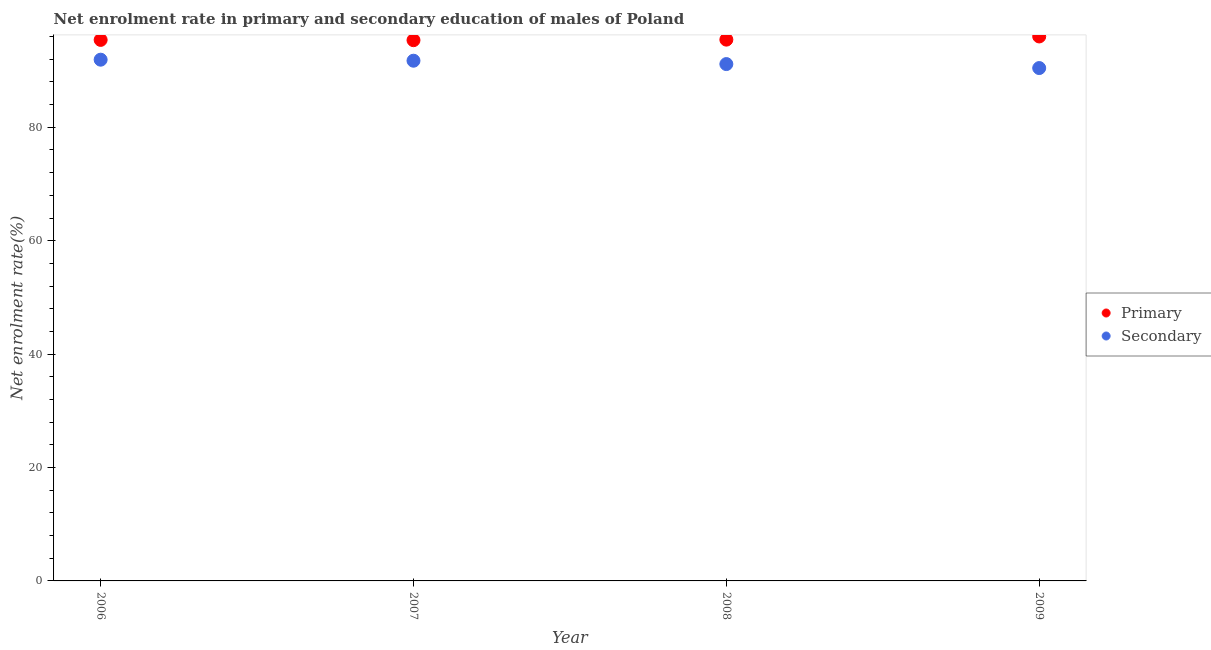How many different coloured dotlines are there?
Ensure brevity in your answer.  2. Is the number of dotlines equal to the number of legend labels?
Your answer should be very brief. Yes. What is the enrollment rate in secondary education in 2008?
Offer a terse response. 91.15. Across all years, what is the maximum enrollment rate in primary education?
Offer a very short reply. 96.02. Across all years, what is the minimum enrollment rate in primary education?
Your answer should be very brief. 95.36. What is the total enrollment rate in secondary education in the graph?
Ensure brevity in your answer.  365.26. What is the difference between the enrollment rate in secondary education in 2008 and that in 2009?
Make the answer very short. 0.7. What is the difference between the enrollment rate in secondary education in 2009 and the enrollment rate in primary education in 2008?
Provide a succinct answer. -5.01. What is the average enrollment rate in secondary education per year?
Your answer should be very brief. 91.32. In the year 2007, what is the difference between the enrollment rate in primary education and enrollment rate in secondary education?
Give a very brief answer. 3.62. In how many years, is the enrollment rate in primary education greater than 16 %?
Make the answer very short. 4. What is the ratio of the enrollment rate in secondary education in 2008 to that in 2009?
Your answer should be compact. 1.01. Is the enrollment rate in secondary education in 2008 less than that in 2009?
Offer a terse response. No. What is the difference between the highest and the second highest enrollment rate in secondary education?
Keep it short and to the point. 0.18. What is the difference between the highest and the lowest enrollment rate in primary education?
Ensure brevity in your answer.  0.66. Is the sum of the enrollment rate in secondary education in 2007 and 2009 greater than the maximum enrollment rate in primary education across all years?
Provide a short and direct response. Yes. Does the enrollment rate in primary education monotonically increase over the years?
Your answer should be compact. No. Is the enrollment rate in primary education strictly less than the enrollment rate in secondary education over the years?
Make the answer very short. No. What is the difference between two consecutive major ticks on the Y-axis?
Your response must be concise. 20. Are the values on the major ticks of Y-axis written in scientific E-notation?
Your answer should be compact. No. Does the graph contain any zero values?
Provide a succinct answer. No. Does the graph contain grids?
Your answer should be compact. No. How many legend labels are there?
Provide a short and direct response. 2. What is the title of the graph?
Make the answer very short. Net enrolment rate in primary and secondary education of males of Poland. What is the label or title of the X-axis?
Provide a succinct answer. Year. What is the label or title of the Y-axis?
Your answer should be very brief. Net enrolment rate(%). What is the Net enrolment rate(%) of Primary in 2006?
Provide a succinct answer. 95.41. What is the Net enrolment rate(%) in Secondary in 2006?
Your answer should be very brief. 91.92. What is the Net enrolment rate(%) of Primary in 2007?
Offer a very short reply. 95.36. What is the Net enrolment rate(%) in Secondary in 2007?
Offer a terse response. 91.74. What is the Net enrolment rate(%) of Primary in 2008?
Keep it short and to the point. 95.46. What is the Net enrolment rate(%) in Secondary in 2008?
Provide a succinct answer. 91.15. What is the Net enrolment rate(%) in Primary in 2009?
Offer a very short reply. 96.02. What is the Net enrolment rate(%) in Secondary in 2009?
Give a very brief answer. 90.45. Across all years, what is the maximum Net enrolment rate(%) in Primary?
Keep it short and to the point. 96.02. Across all years, what is the maximum Net enrolment rate(%) of Secondary?
Your answer should be compact. 91.92. Across all years, what is the minimum Net enrolment rate(%) of Primary?
Your response must be concise. 95.36. Across all years, what is the minimum Net enrolment rate(%) of Secondary?
Offer a very short reply. 90.45. What is the total Net enrolment rate(%) of Primary in the graph?
Provide a short and direct response. 382.26. What is the total Net enrolment rate(%) of Secondary in the graph?
Your answer should be very brief. 365.26. What is the difference between the Net enrolment rate(%) in Primary in 2006 and that in 2007?
Provide a short and direct response. 0.05. What is the difference between the Net enrolment rate(%) in Secondary in 2006 and that in 2007?
Ensure brevity in your answer.  0.18. What is the difference between the Net enrolment rate(%) in Primary in 2006 and that in 2008?
Offer a terse response. -0.05. What is the difference between the Net enrolment rate(%) in Secondary in 2006 and that in 2008?
Offer a terse response. 0.77. What is the difference between the Net enrolment rate(%) of Primary in 2006 and that in 2009?
Offer a very short reply. -0.61. What is the difference between the Net enrolment rate(%) in Secondary in 2006 and that in 2009?
Your answer should be very brief. 1.48. What is the difference between the Net enrolment rate(%) in Primary in 2007 and that in 2008?
Your answer should be compact. -0.1. What is the difference between the Net enrolment rate(%) of Secondary in 2007 and that in 2008?
Give a very brief answer. 0.59. What is the difference between the Net enrolment rate(%) in Primary in 2007 and that in 2009?
Make the answer very short. -0.66. What is the difference between the Net enrolment rate(%) of Secondary in 2007 and that in 2009?
Provide a succinct answer. 1.3. What is the difference between the Net enrolment rate(%) in Primary in 2008 and that in 2009?
Ensure brevity in your answer.  -0.56. What is the difference between the Net enrolment rate(%) of Secondary in 2008 and that in 2009?
Provide a succinct answer. 0.7. What is the difference between the Net enrolment rate(%) in Primary in 2006 and the Net enrolment rate(%) in Secondary in 2007?
Provide a short and direct response. 3.67. What is the difference between the Net enrolment rate(%) in Primary in 2006 and the Net enrolment rate(%) in Secondary in 2008?
Provide a succinct answer. 4.26. What is the difference between the Net enrolment rate(%) of Primary in 2006 and the Net enrolment rate(%) of Secondary in 2009?
Keep it short and to the point. 4.97. What is the difference between the Net enrolment rate(%) in Primary in 2007 and the Net enrolment rate(%) in Secondary in 2008?
Give a very brief answer. 4.21. What is the difference between the Net enrolment rate(%) of Primary in 2007 and the Net enrolment rate(%) of Secondary in 2009?
Offer a very short reply. 4.92. What is the difference between the Net enrolment rate(%) of Primary in 2008 and the Net enrolment rate(%) of Secondary in 2009?
Offer a very short reply. 5.01. What is the average Net enrolment rate(%) in Primary per year?
Give a very brief answer. 95.56. What is the average Net enrolment rate(%) in Secondary per year?
Offer a very short reply. 91.32. In the year 2006, what is the difference between the Net enrolment rate(%) in Primary and Net enrolment rate(%) in Secondary?
Keep it short and to the point. 3.49. In the year 2007, what is the difference between the Net enrolment rate(%) in Primary and Net enrolment rate(%) in Secondary?
Make the answer very short. 3.62. In the year 2008, what is the difference between the Net enrolment rate(%) of Primary and Net enrolment rate(%) of Secondary?
Offer a terse response. 4.31. In the year 2009, what is the difference between the Net enrolment rate(%) in Primary and Net enrolment rate(%) in Secondary?
Your response must be concise. 5.57. What is the ratio of the Net enrolment rate(%) in Secondary in 2006 to that in 2008?
Make the answer very short. 1.01. What is the ratio of the Net enrolment rate(%) of Primary in 2006 to that in 2009?
Make the answer very short. 0.99. What is the ratio of the Net enrolment rate(%) in Secondary in 2006 to that in 2009?
Your answer should be very brief. 1.02. What is the ratio of the Net enrolment rate(%) in Secondary in 2007 to that in 2008?
Your answer should be compact. 1.01. What is the ratio of the Net enrolment rate(%) of Secondary in 2007 to that in 2009?
Ensure brevity in your answer.  1.01. What is the ratio of the Net enrolment rate(%) in Primary in 2008 to that in 2009?
Keep it short and to the point. 0.99. What is the ratio of the Net enrolment rate(%) of Secondary in 2008 to that in 2009?
Provide a succinct answer. 1.01. What is the difference between the highest and the second highest Net enrolment rate(%) in Primary?
Provide a succinct answer. 0.56. What is the difference between the highest and the second highest Net enrolment rate(%) of Secondary?
Keep it short and to the point. 0.18. What is the difference between the highest and the lowest Net enrolment rate(%) in Primary?
Offer a terse response. 0.66. What is the difference between the highest and the lowest Net enrolment rate(%) in Secondary?
Your answer should be compact. 1.48. 